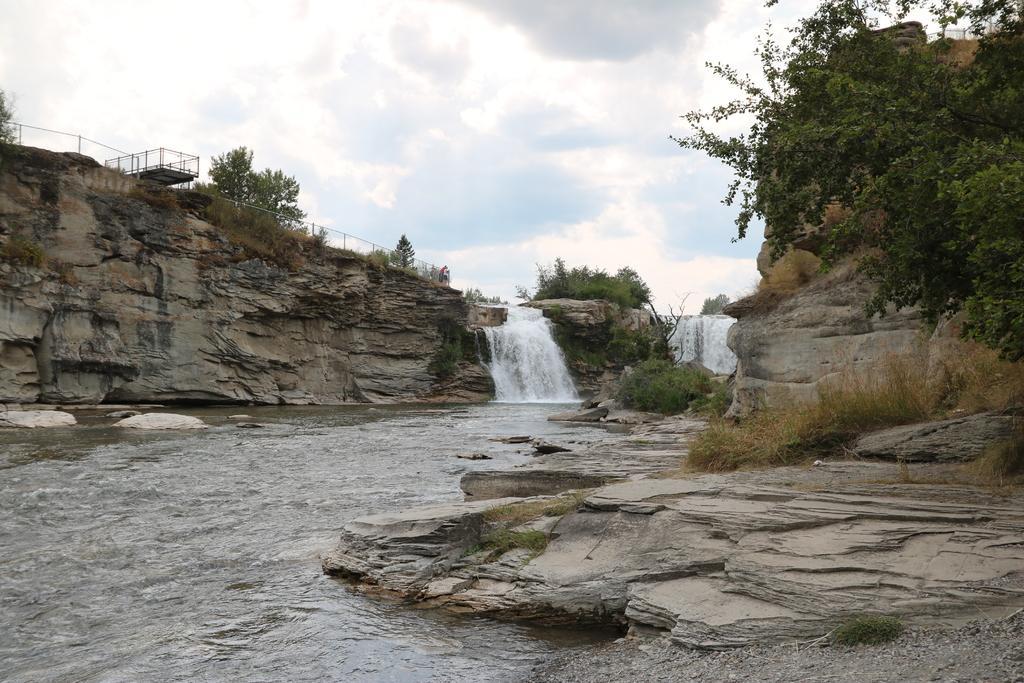How would you summarize this image in a sentence or two? It is a waterfall the water is flowing from a hill and on the left side above the hill there is a fencing and behind the fencing there are many trees. 